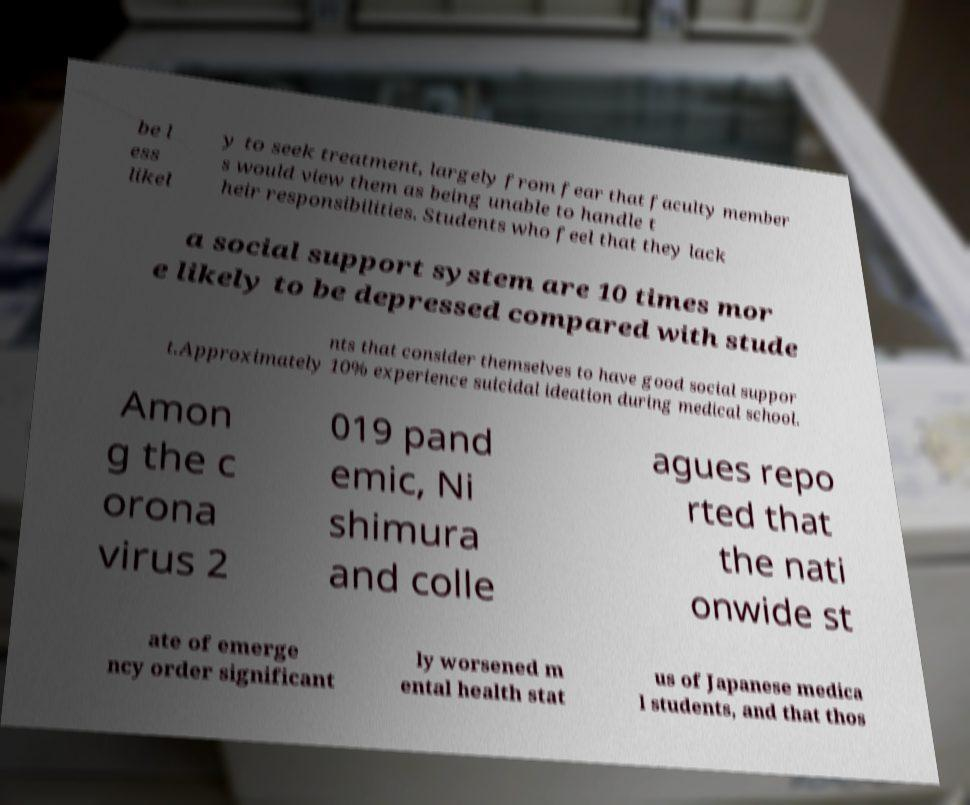Please read and relay the text visible in this image. What does it say? be l ess likel y to seek treatment, largely from fear that faculty member s would view them as being unable to handle t heir responsibilities. Students who feel that they lack a social support system are 10 times mor e likely to be depressed compared with stude nts that consider themselves to have good social suppor t.Approximately 10% experience suicidal ideation during medical school. Amon g the c orona virus 2 019 pand emic, Ni shimura and colle agues repo rted that the nati onwide st ate of emerge ncy order significant ly worsened m ental health stat us of Japanese medica l students, and that thos 